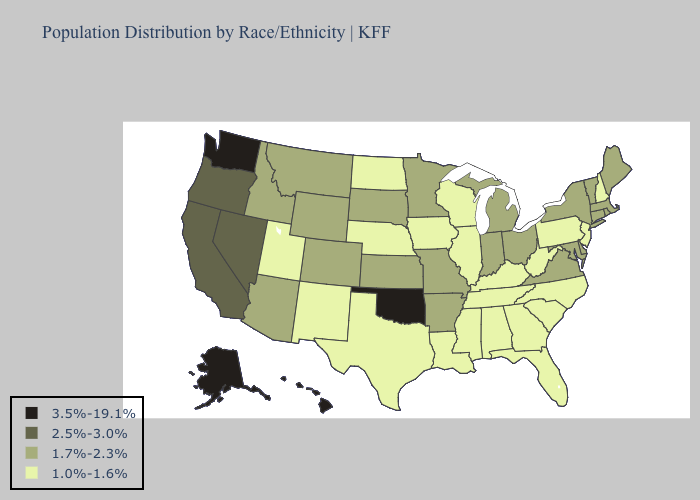Among the states that border Colorado , does New Mexico have the lowest value?
Short answer required. Yes. Does New Hampshire have the lowest value in the USA?
Keep it brief. Yes. What is the highest value in the West ?
Write a very short answer. 3.5%-19.1%. Does Colorado have the same value as Illinois?
Quick response, please. No. What is the value of Connecticut?
Keep it brief. 1.7%-2.3%. What is the highest value in states that border Rhode Island?
Concise answer only. 1.7%-2.3%. Which states have the highest value in the USA?
Be succinct. Alaska, Hawaii, Oklahoma, Washington. Name the states that have a value in the range 1.0%-1.6%?
Keep it brief. Alabama, Florida, Georgia, Illinois, Iowa, Kentucky, Louisiana, Mississippi, Nebraska, New Hampshire, New Jersey, New Mexico, North Carolina, North Dakota, Pennsylvania, South Carolina, Tennessee, Texas, Utah, West Virginia, Wisconsin. What is the highest value in the Northeast ?
Keep it brief. 1.7%-2.3%. Which states hav the highest value in the West?
Write a very short answer. Alaska, Hawaii, Washington. What is the lowest value in the MidWest?
Concise answer only. 1.0%-1.6%. What is the value of Mississippi?
Give a very brief answer. 1.0%-1.6%. What is the value of Washington?
Short answer required. 3.5%-19.1%. Name the states that have a value in the range 2.5%-3.0%?
Answer briefly. California, Nevada, Oregon. 